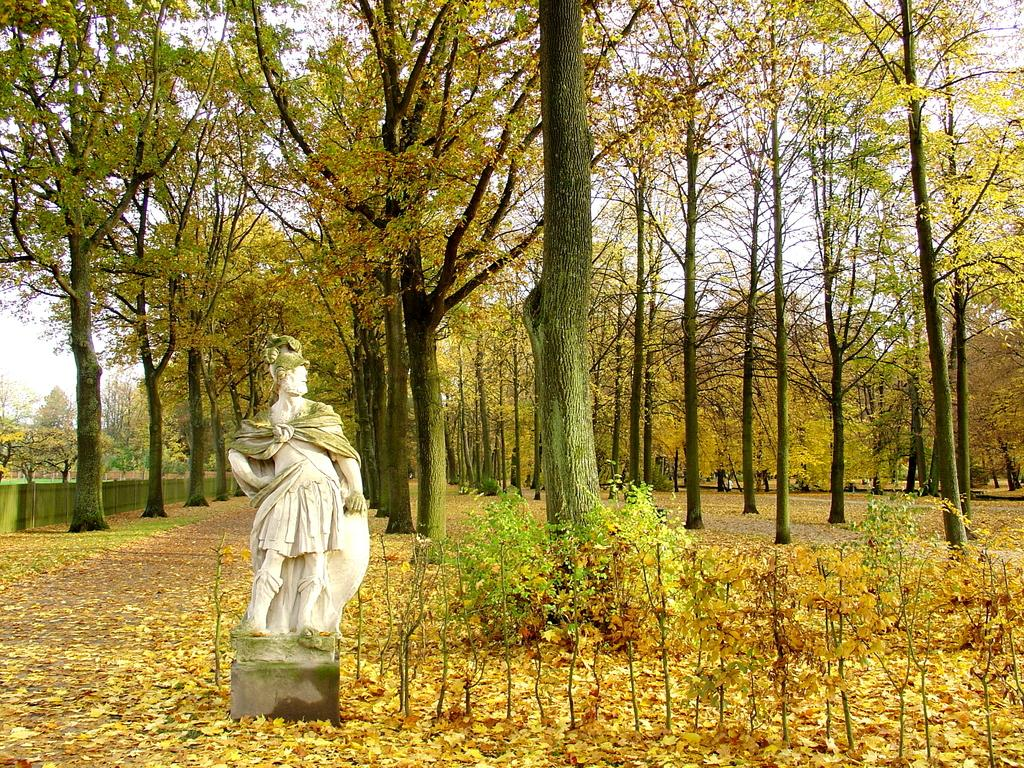What is the main subject in the image? There is a statue in the image. What other elements can be seen in the image besides the statue? There are plants and trees in the image. What is visible at the top of the image? The sky is visible at the top of the image. What type of amusement can be seen in the image? There is no amusement present in the image; it features a statue, plants, trees, and the sky. What is the location of the statue in relation to downtown? The provided facts do not mention the location of the statue in relation to downtown, so it cannot be determined from the image. 